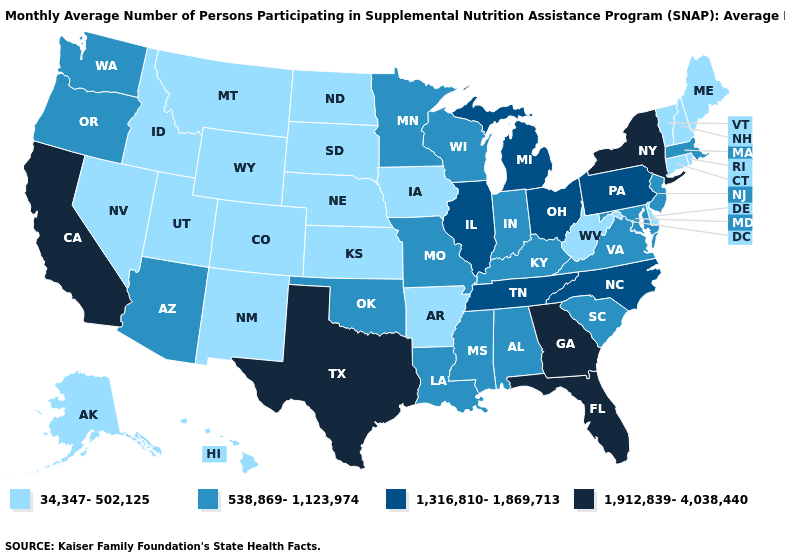Among the states that border Vermont , which have the lowest value?
Short answer required. New Hampshire. Name the states that have a value in the range 538,869-1,123,974?
Be succinct. Alabama, Arizona, Indiana, Kentucky, Louisiana, Maryland, Massachusetts, Minnesota, Mississippi, Missouri, New Jersey, Oklahoma, Oregon, South Carolina, Virginia, Washington, Wisconsin. Name the states that have a value in the range 1,316,810-1,869,713?
Answer briefly. Illinois, Michigan, North Carolina, Ohio, Pennsylvania, Tennessee. Does Tennessee have the same value as Michigan?
Short answer required. Yes. How many symbols are there in the legend?
Quick response, please. 4. Name the states that have a value in the range 1,316,810-1,869,713?
Write a very short answer. Illinois, Michigan, North Carolina, Ohio, Pennsylvania, Tennessee. Does the first symbol in the legend represent the smallest category?
Concise answer only. Yes. Does the map have missing data?
Keep it brief. No. Name the states that have a value in the range 34,347-502,125?
Be succinct. Alaska, Arkansas, Colorado, Connecticut, Delaware, Hawaii, Idaho, Iowa, Kansas, Maine, Montana, Nebraska, Nevada, New Hampshire, New Mexico, North Dakota, Rhode Island, South Dakota, Utah, Vermont, West Virginia, Wyoming. Among the states that border Montana , which have the highest value?
Be succinct. Idaho, North Dakota, South Dakota, Wyoming. Name the states that have a value in the range 538,869-1,123,974?
Concise answer only. Alabama, Arizona, Indiana, Kentucky, Louisiana, Maryland, Massachusetts, Minnesota, Mississippi, Missouri, New Jersey, Oklahoma, Oregon, South Carolina, Virginia, Washington, Wisconsin. Does the first symbol in the legend represent the smallest category?
Keep it brief. Yes. Name the states that have a value in the range 538,869-1,123,974?
Concise answer only. Alabama, Arizona, Indiana, Kentucky, Louisiana, Maryland, Massachusetts, Minnesota, Mississippi, Missouri, New Jersey, Oklahoma, Oregon, South Carolina, Virginia, Washington, Wisconsin. What is the value of Mississippi?
Give a very brief answer. 538,869-1,123,974. Which states have the lowest value in the USA?
Answer briefly. Alaska, Arkansas, Colorado, Connecticut, Delaware, Hawaii, Idaho, Iowa, Kansas, Maine, Montana, Nebraska, Nevada, New Hampshire, New Mexico, North Dakota, Rhode Island, South Dakota, Utah, Vermont, West Virginia, Wyoming. 